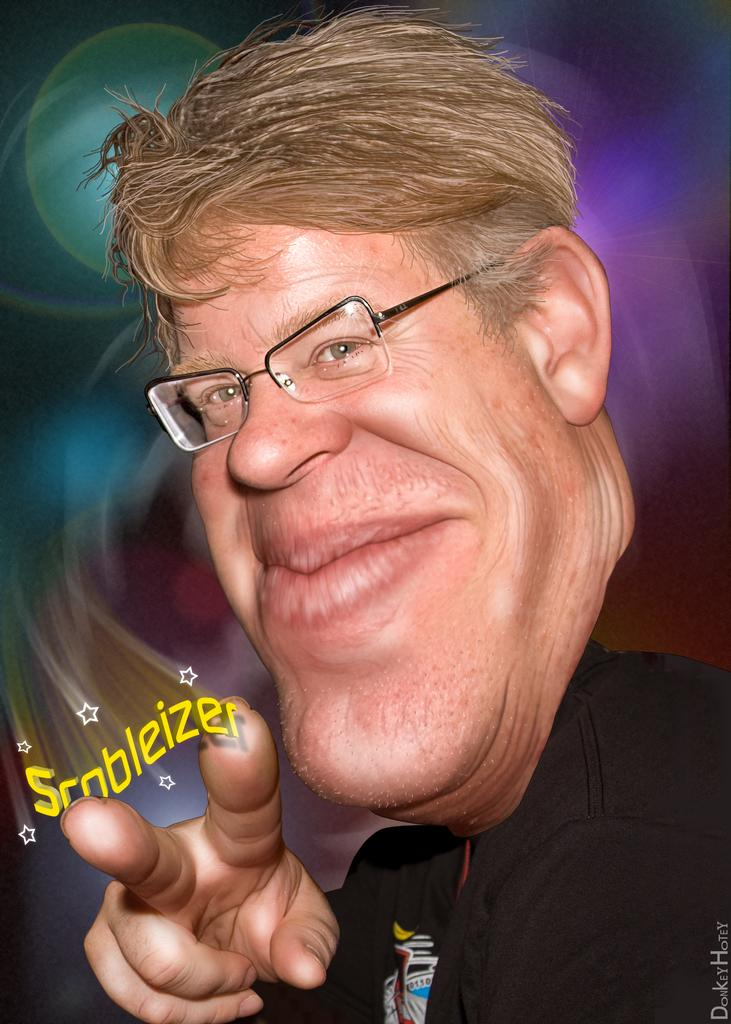What style is the image drawn in? The image is a cartoon. Who is present in the image? There is a man in the image. What accessory is the man wearing? The man is wearing spectacles. Where can text be found in the image? There is text at the bottom left and bottom right corners of the image. What type of store is depicted in the image? There is no store present in the image; it is a cartoon featuring a man wearing spectacles. What action is the man performing in the image? The image does not depict any specific action being performed by the man; he is simply standing with spectacles on. 